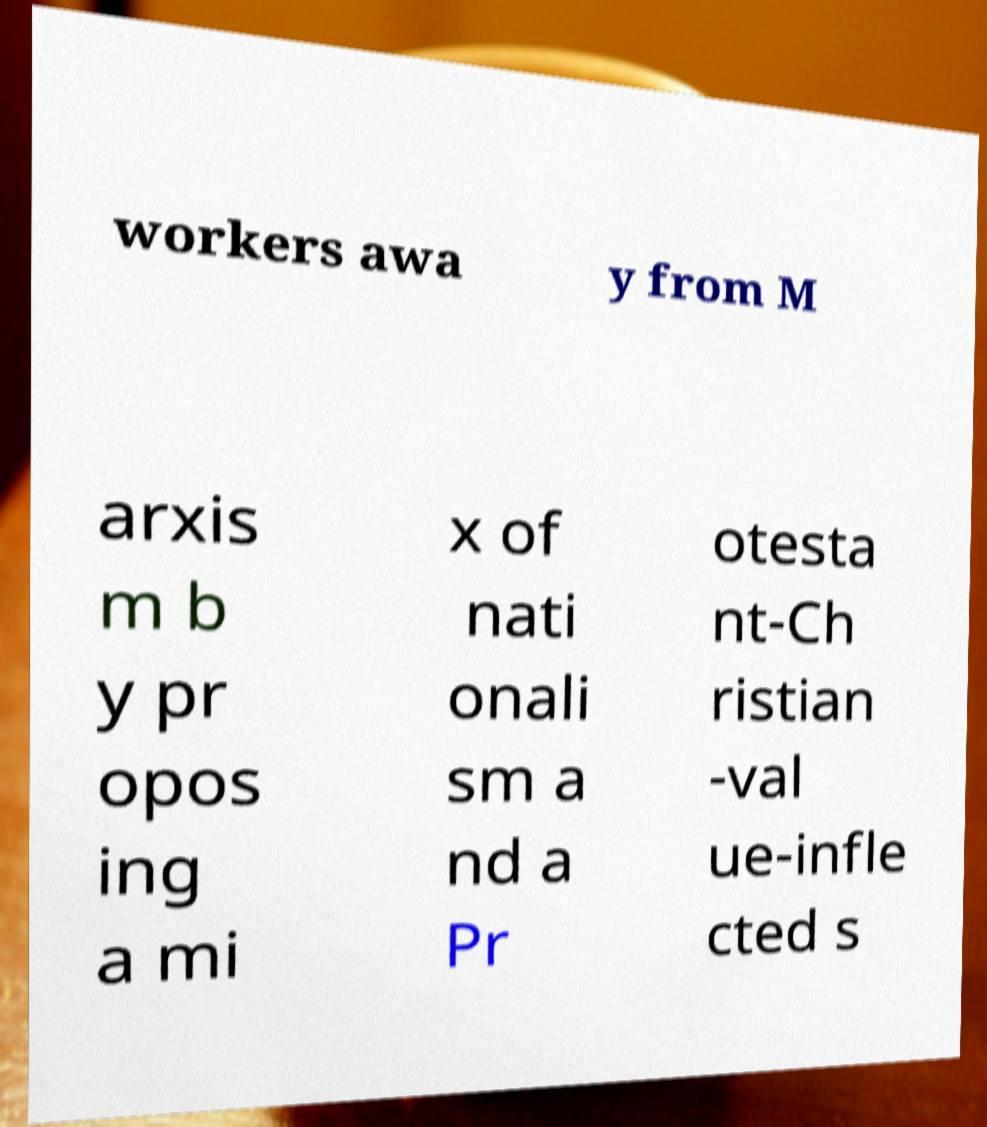There's text embedded in this image that I need extracted. Can you transcribe it verbatim? workers awa y from M arxis m b y pr opos ing a mi x of nati onali sm a nd a Pr otesta nt-Ch ristian -val ue-infle cted s 